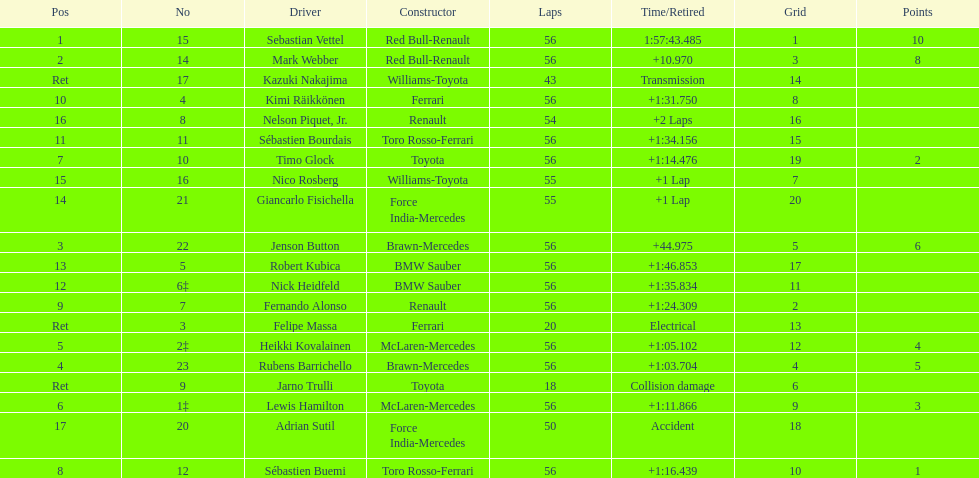What driver was last on the list? Jarno Trulli. Give me the full table as a dictionary. {'header': ['Pos', 'No', 'Driver', 'Constructor', 'Laps', 'Time/Retired', 'Grid', 'Points'], 'rows': [['1', '15', 'Sebastian Vettel', 'Red Bull-Renault', '56', '1:57:43.485', '1', '10'], ['2', '14', 'Mark Webber', 'Red Bull-Renault', '56', '+10.970', '3', '8'], ['Ret', '17', 'Kazuki Nakajima', 'Williams-Toyota', '43', 'Transmission', '14', ''], ['10', '4', 'Kimi Räikkönen', 'Ferrari', '56', '+1:31.750', '8', ''], ['16', '8', 'Nelson Piquet, Jr.', 'Renault', '54', '+2 Laps', '16', ''], ['11', '11', 'Sébastien Bourdais', 'Toro Rosso-Ferrari', '56', '+1:34.156', '15', ''], ['7', '10', 'Timo Glock', 'Toyota', '56', '+1:14.476', '19', '2'], ['15', '16', 'Nico Rosberg', 'Williams-Toyota', '55', '+1 Lap', '7', ''], ['14', '21', 'Giancarlo Fisichella', 'Force India-Mercedes', '55', '+1 Lap', '20', ''], ['3', '22', 'Jenson Button', 'Brawn-Mercedes', '56', '+44.975', '5', '6'], ['13', '5', 'Robert Kubica', 'BMW Sauber', '56', '+1:46.853', '17', ''], ['12', '6‡', 'Nick Heidfeld', 'BMW Sauber', '56', '+1:35.834', '11', ''], ['9', '7', 'Fernando Alonso', 'Renault', '56', '+1:24.309', '2', ''], ['Ret', '3', 'Felipe Massa', 'Ferrari', '20', 'Electrical', '13', ''], ['5', '2‡', 'Heikki Kovalainen', 'McLaren-Mercedes', '56', '+1:05.102', '12', '4'], ['4', '23', 'Rubens Barrichello', 'Brawn-Mercedes', '56', '+1:03.704', '4', '5'], ['Ret', '9', 'Jarno Trulli', 'Toyota', '18', 'Collision damage', '6', ''], ['6', '1‡', 'Lewis Hamilton', 'McLaren-Mercedes', '56', '+1:11.866', '9', '3'], ['17', '20', 'Adrian Sutil', 'Force India-Mercedes', '50', 'Accident', '18', ''], ['8', '12', 'Sébastien Buemi', 'Toro Rosso-Ferrari', '56', '+1:16.439', '10', '1']]} 